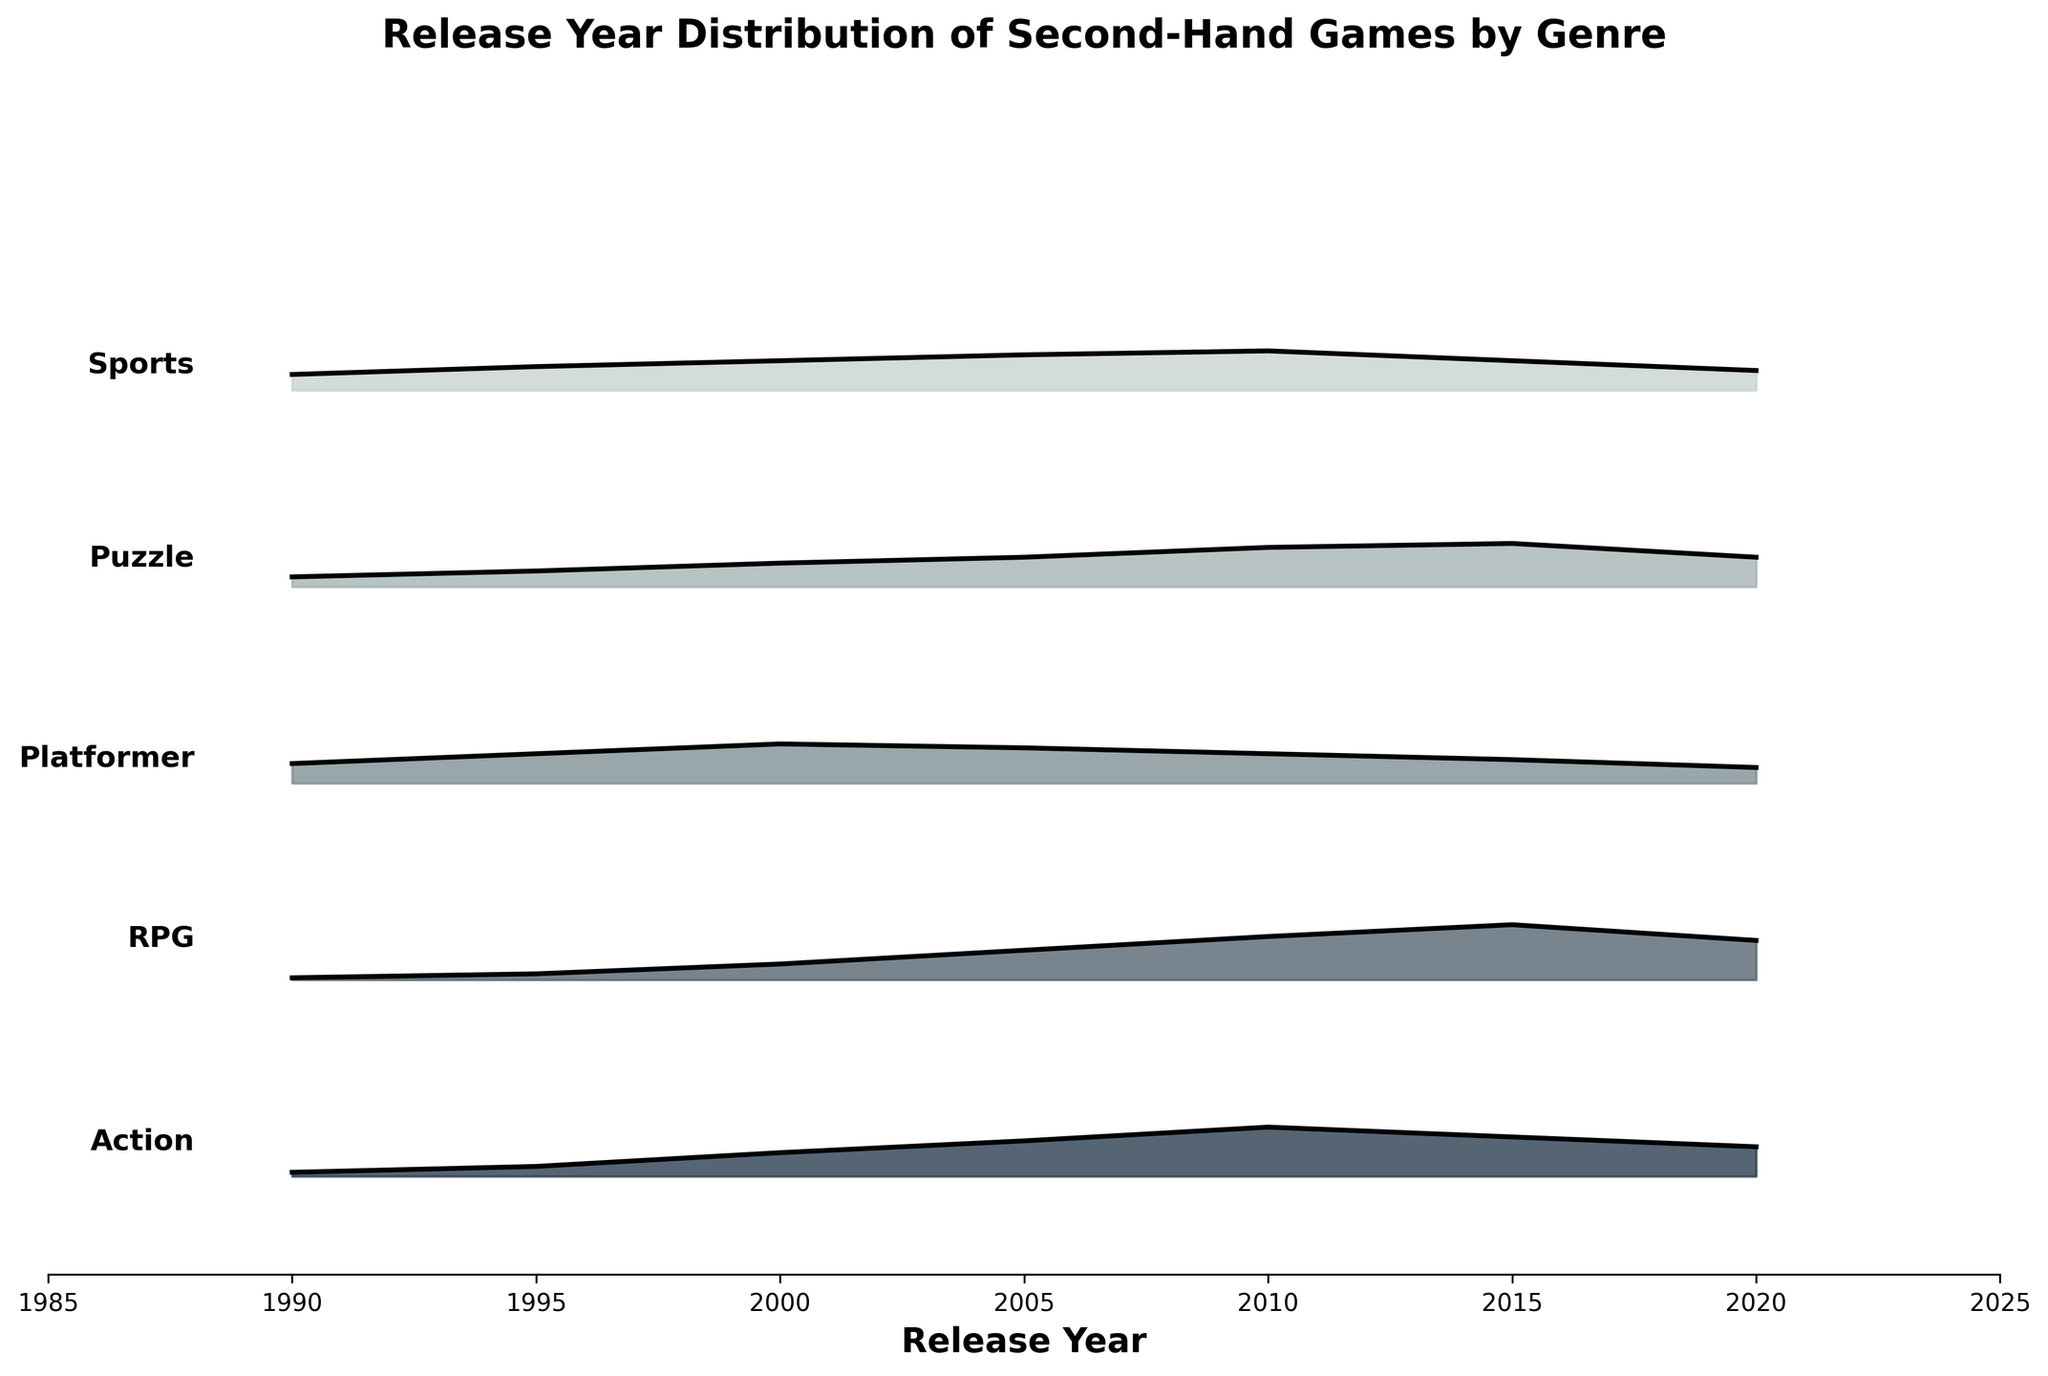what is the title of the plot? The title is located at the top of the plot and describes the main subject of the visualization, which is the distribution of second-hand games by their release year across different genres.
Answer: Release Year Distribution of Second-Hand Games by Genre Which genre has the highest density in 2015? By looking along the 2015 mark on the x-axis, you can see which genre has the highest peak. The RPG genre has the highest density at the 2015 mark.
Answer: RPG What is the general trend of density for Action games from 1990 to 2020? Starting from 1990, the density of Action games rises gradually, peaking around 2010 before it starts to decline heading towards 2020.
Answer: Rises then falls Across which years do Platformer games have a density greater than 0.15? Observing the y-values for Platformer games, it can be seen that the density surpasses 0.15 from roughly 1995 to 2005.
Answer: 1995 to 2005 How does the density of Puzzle games in 2005 compare to their density in 2020? Comparing the heights at 2005 and 2020 for Puzzle games, the density in 2005 is slightly higher than in 2020.
Answer: Higher in 2005 Which genre shows a decline in density after 2010? By observing the trends after 2010 for each genre, both Action and Platformer games show a decline in density.
Answer: Action and Platformer What is the density of Sports games in 2010? By locating the 2010 mark on the axis and checking the height of the Sports genre curve, the density is around 0.20.
Answer: 0.20 In which year did RPG games start becoming more popular than Action games? By comparing the heights of the RPG and Action density curves across the years, RPG games surpass the density of Action games around 2015.
Answer: 2015 What pattern is observed in the density of Puzzle games from 1990 to 2020? Starting at 1990, the density of Puzzle games increases steadily until peaking around 2015 and then slightly declines by 2020.
Answer: Steadily increases then declines Which genre had a steady density decrease from 2000 to 2020? Looking at the trends from 2000 to 2020, Platformer games steadily decrease without significant peaks or increases.
Answer: Platformer 